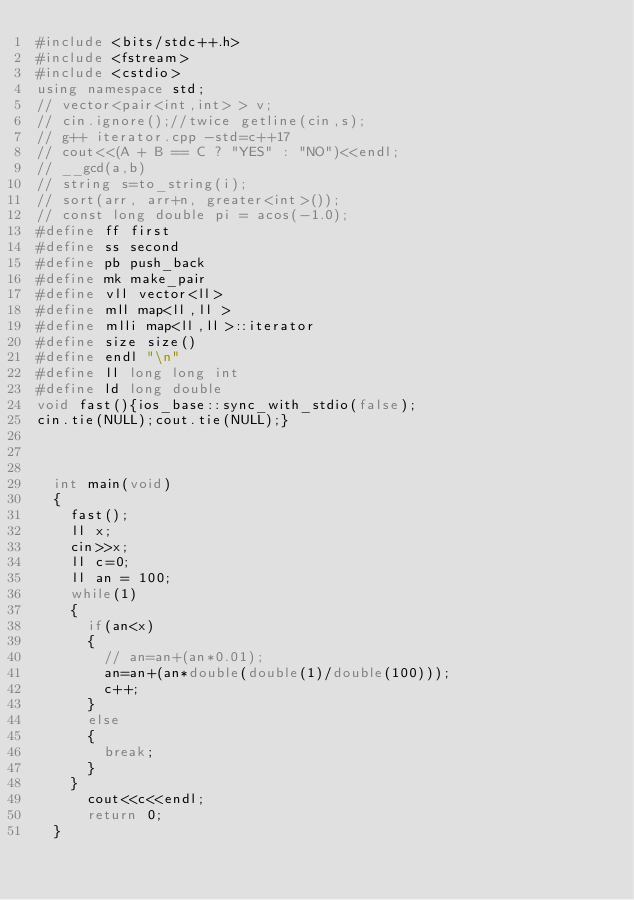Convert code to text. <code><loc_0><loc_0><loc_500><loc_500><_C++_>#include <bits/stdc++.h>
#include <fstream>
#include <cstdio>
using namespace std;
// vector<pair<int,int> > v;
// cin.ignore();//twice getline(cin,s);
// g++ iterator.cpp -std=c++17
// cout<<(A + B == C ? "YES" : "NO")<<endl;
// __gcd(a,b)
// string s=to_string(i);
// sort(arr, arr+n, greater<int>());
// const long double pi = acos(-1.0);
#define ff first
#define ss second
#define pb push_back
#define mk make_pair
#define vll vector<ll>
#define mll map<ll,ll >
#define mlli map<ll,ll>::iterator
#define size size()
#define endl "\n"
#define ll long long int
#define ld long double
void fast(){ios_base::sync_with_stdio(false);
cin.tie(NULL);cout.tie(NULL);}



	int main(void)
	{
		fast();
		ll x;
		cin>>x;
		ll c=0;
		ll an = 100;
		while(1)
		{
			if(an<x)
			{
				// an=an+(an*0.01);
				an=an+(an*double(double(1)/double(100)));
				c++;
			}
			else
			{
				break;
			}
		}
	    cout<<c<<endl;
	    return 0;
	}</code> 